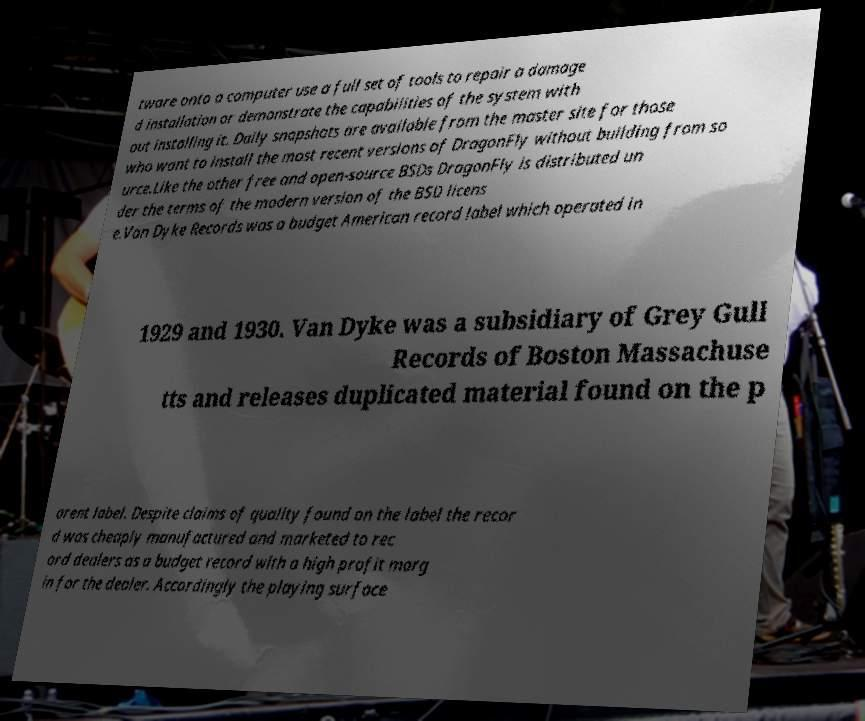Please read and relay the text visible in this image. What does it say? tware onto a computer use a full set of tools to repair a damage d installation or demonstrate the capabilities of the system with out installing it. Daily snapshots are available from the master site for those who want to install the most recent versions of DragonFly without building from so urce.Like the other free and open-source BSDs DragonFly is distributed un der the terms of the modern version of the BSD licens e.Van Dyke Records was a budget American record label which operated in 1929 and 1930. Van Dyke was a subsidiary of Grey Gull Records of Boston Massachuse tts and releases duplicated material found on the p arent label. Despite claims of quality found on the label the recor d was cheaply manufactured and marketed to rec ord dealers as a budget record with a high profit marg in for the dealer. Accordingly the playing surface 